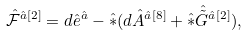Convert formula to latex. <formula><loc_0><loc_0><loc_500><loc_500>\hat { \mathcal { F } } ^ { { \hat { a } } [ 2 ] } = d \hat { e } ^ { \hat { a } } - \hat { \ast } ( d \hat { A } ^ { { \hat { a } } [ 8 ] } + \hat { \ast } \hat { \tilde { G } } ^ { { \hat { a } } [ 2 ] } ) ,</formula> 